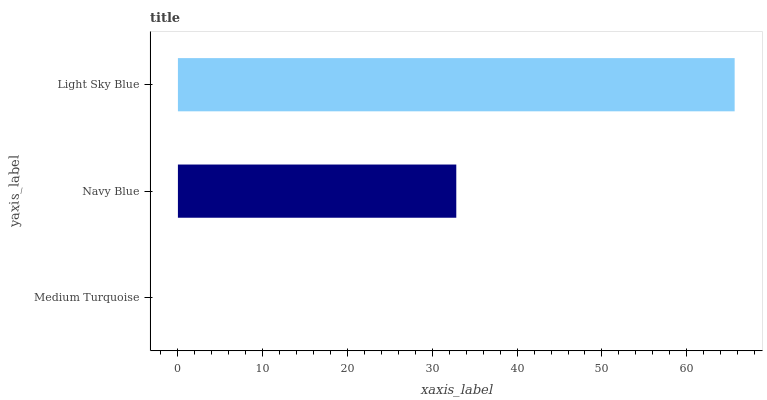Is Medium Turquoise the minimum?
Answer yes or no. Yes. Is Light Sky Blue the maximum?
Answer yes or no. Yes. Is Navy Blue the minimum?
Answer yes or no. No. Is Navy Blue the maximum?
Answer yes or no. No. Is Navy Blue greater than Medium Turquoise?
Answer yes or no. Yes. Is Medium Turquoise less than Navy Blue?
Answer yes or no. Yes. Is Medium Turquoise greater than Navy Blue?
Answer yes or no. No. Is Navy Blue less than Medium Turquoise?
Answer yes or no. No. Is Navy Blue the high median?
Answer yes or no. Yes. Is Navy Blue the low median?
Answer yes or no. Yes. Is Medium Turquoise the high median?
Answer yes or no. No. Is Medium Turquoise the low median?
Answer yes or no. No. 